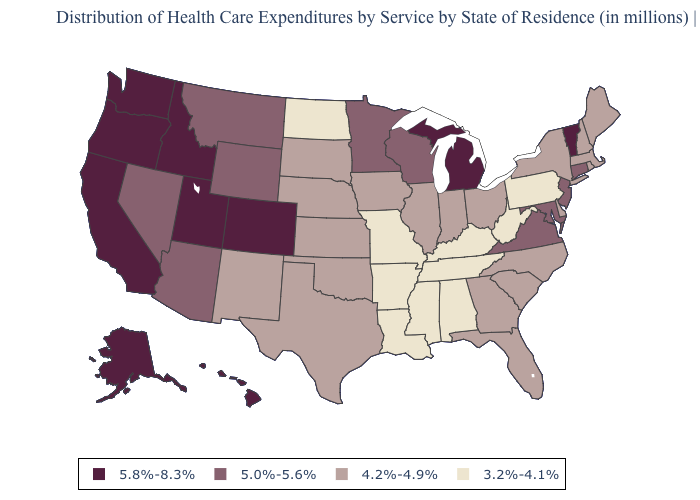What is the value of Louisiana?
Be succinct. 3.2%-4.1%. What is the value of Utah?
Be succinct. 5.8%-8.3%. How many symbols are there in the legend?
Write a very short answer. 4. What is the highest value in states that border Georgia?
Quick response, please. 4.2%-4.9%. Is the legend a continuous bar?
Short answer required. No. Name the states that have a value in the range 4.2%-4.9%?
Keep it brief. Delaware, Florida, Georgia, Illinois, Indiana, Iowa, Kansas, Maine, Massachusetts, Nebraska, New Hampshire, New Mexico, New York, North Carolina, Ohio, Oklahoma, Rhode Island, South Carolina, South Dakota, Texas. Name the states that have a value in the range 5.0%-5.6%?
Answer briefly. Arizona, Connecticut, Maryland, Minnesota, Montana, Nevada, New Jersey, Virginia, Wisconsin, Wyoming. Does Vermont have a higher value than Georgia?
Answer briefly. Yes. Name the states that have a value in the range 4.2%-4.9%?
Concise answer only. Delaware, Florida, Georgia, Illinois, Indiana, Iowa, Kansas, Maine, Massachusetts, Nebraska, New Hampshire, New Mexico, New York, North Carolina, Ohio, Oklahoma, Rhode Island, South Carolina, South Dakota, Texas. What is the highest value in states that border Nebraska?
Answer briefly. 5.8%-8.3%. Which states hav the highest value in the South?
Concise answer only. Maryland, Virginia. Name the states that have a value in the range 5.0%-5.6%?
Answer briefly. Arizona, Connecticut, Maryland, Minnesota, Montana, Nevada, New Jersey, Virginia, Wisconsin, Wyoming. What is the lowest value in states that border North Dakota?
Write a very short answer. 4.2%-4.9%. What is the highest value in the South ?
Answer briefly. 5.0%-5.6%. Does North Dakota have the lowest value in the USA?
Short answer required. Yes. 